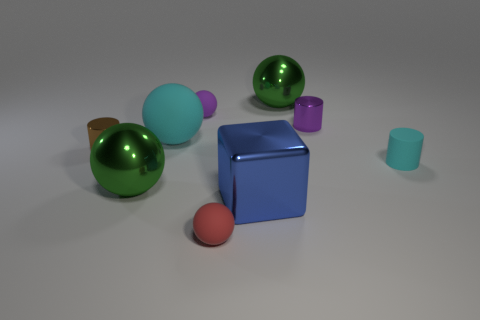What color is the large matte thing that is the same shape as the tiny red object?
Offer a very short reply. Cyan. How many shiny things are either large blocks or purple cylinders?
Your answer should be very brief. 2. Is there a green sphere in front of the large green ball on the right side of the green object left of the large cyan matte ball?
Make the answer very short. Yes. The big block has what color?
Your response must be concise. Blue. Does the cyan rubber object that is behind the tiny brown cylinder have the same shape as the tiny cyan rubber thing?
Offer a very short reply. No. How many objects are either cyan metallic blocks or cyan things behind the cyan cylinder?
Provide a short and direct response. 1. Do the cyan thing that is to the right of the big metal cube and the big cyan sphere have the same material?
Ensure brevity in your answer.  Yes. Is there anything else that has the same size as the purple rubber thing?
Make the answer very short. Yes. What is the material of the object left of the large green sphere that is to the left of the big blue metallic block?
Keep it short and to the point. Metal. Is the number of purple matte things that are on the left side of the tiny brown metallic thing greater than the number of small metallic cylinders that are on the left side of the cyan ball?
Give a very brief answer. No. 